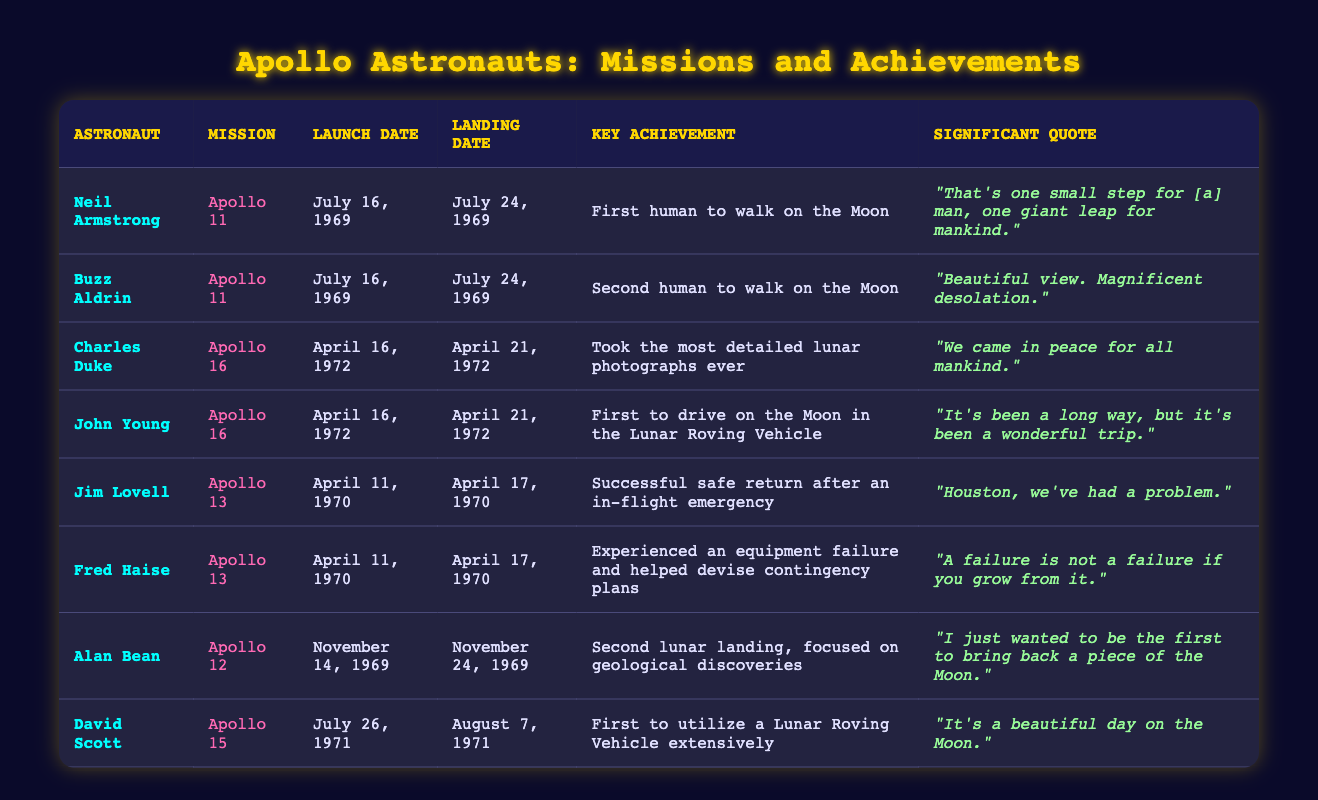What was the key achievement of Neil Armstrong during Apollo 11? Neil Armstrong's key achievement during Apollo 11 was that he became the first human to walk on the Moon. This information is specifically listed in his corresponding row in the table.
Answer: First human to walk on the Moon On which date did Apollo 13 launch? The launch date of Apollo 13 is clearly mentioned in the table under the relevant row for Jim Lovell and Fred Haise, which is April 11, 1970.
Answer: April 11, 1970 How many astronauts walked on the Moon during Apollo 11? Apollo 11 had two astronauts who walked on the Moon: Neil Armstrong and Buzz Aldrin. By checking the table, both astronauts are listed under Apollo 11, making the total count two.
Answer: 2 Which mission featured the first use of a Lunar Roving Vehicle? The mission that featured the first extensive use of a Lunar Roving Vehicle was Apollo 15, where David Scott is noted for utilizing it extensively. This observation can be seen in the table.
Answer: Apollo 15 Is it true that Jim Lovell's mission was a successful return after an emergency? Yes, it is true. The table indicates that Jim Lovell was part of Apollo 13, which had an in-flight emergency but achieved a successful safe return. Hence, the statement is verified as correct.
Answer: Yes Who made the quote, "We came in peace for all mankind."? This quote comes from Charles Duke during his mission on Apollo 16. By referring to the relevant row in the table, one can find this specific quote attributed to him.
Answer: Charles Duke Which two astronauts were part of Apollo 12, and what was significant about their landing? Apollo 12's notable astronauts were Alan Bean and Charles Duke, with Bean's significant achievement being the second lunar landing that focused on geological discoveries. The table provides both names and details relevant to their mission.
Answer: Alan Bean, Charles Duke How many days were between launch and landing for Apollo 15? Apollo 15 launched on July 26, 1971, and landed on August 7, 1971. Counting the days from launch to landing gives a total of 12 days. The difference between these two dates shows the duration of the mission.
Answer: 12 days What was the main focus of the Apollo 11 mission? The main focus of the Apollo 11 mission, as indicated by the achievements of the astronauts involved, was the lunar landing, which involved Neil Armstrong being the first person to walk on the Moon. The table highlights this key aspect.
Answer: Lunar landing 